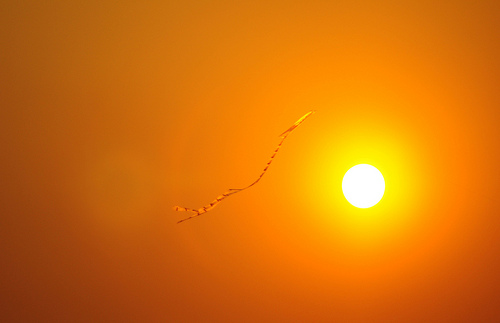<image>
Is there a kite in front of the sun? Yes. The kite is positioned in front of the sun, appearing closer to the camera viewpoint. 